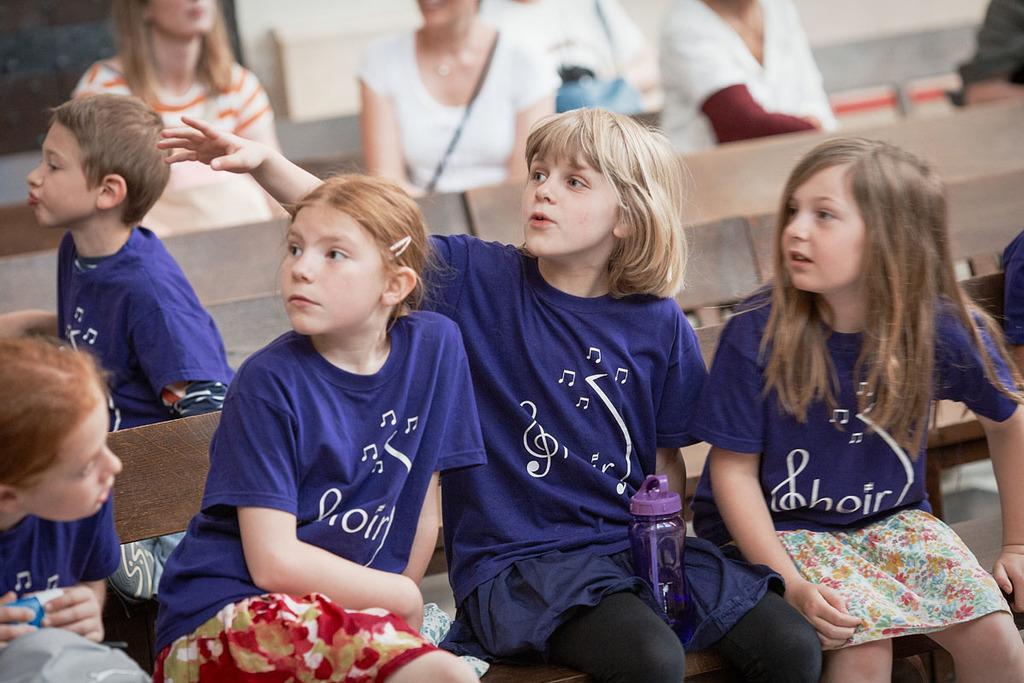Could you give a brief overview of what you see in this image? In the foreground of this picture, there are four girl in purple T shirt are sitting on a bench. In the background there is a boy sitting and few person in the background are sitting on the bench and there is a wall. 